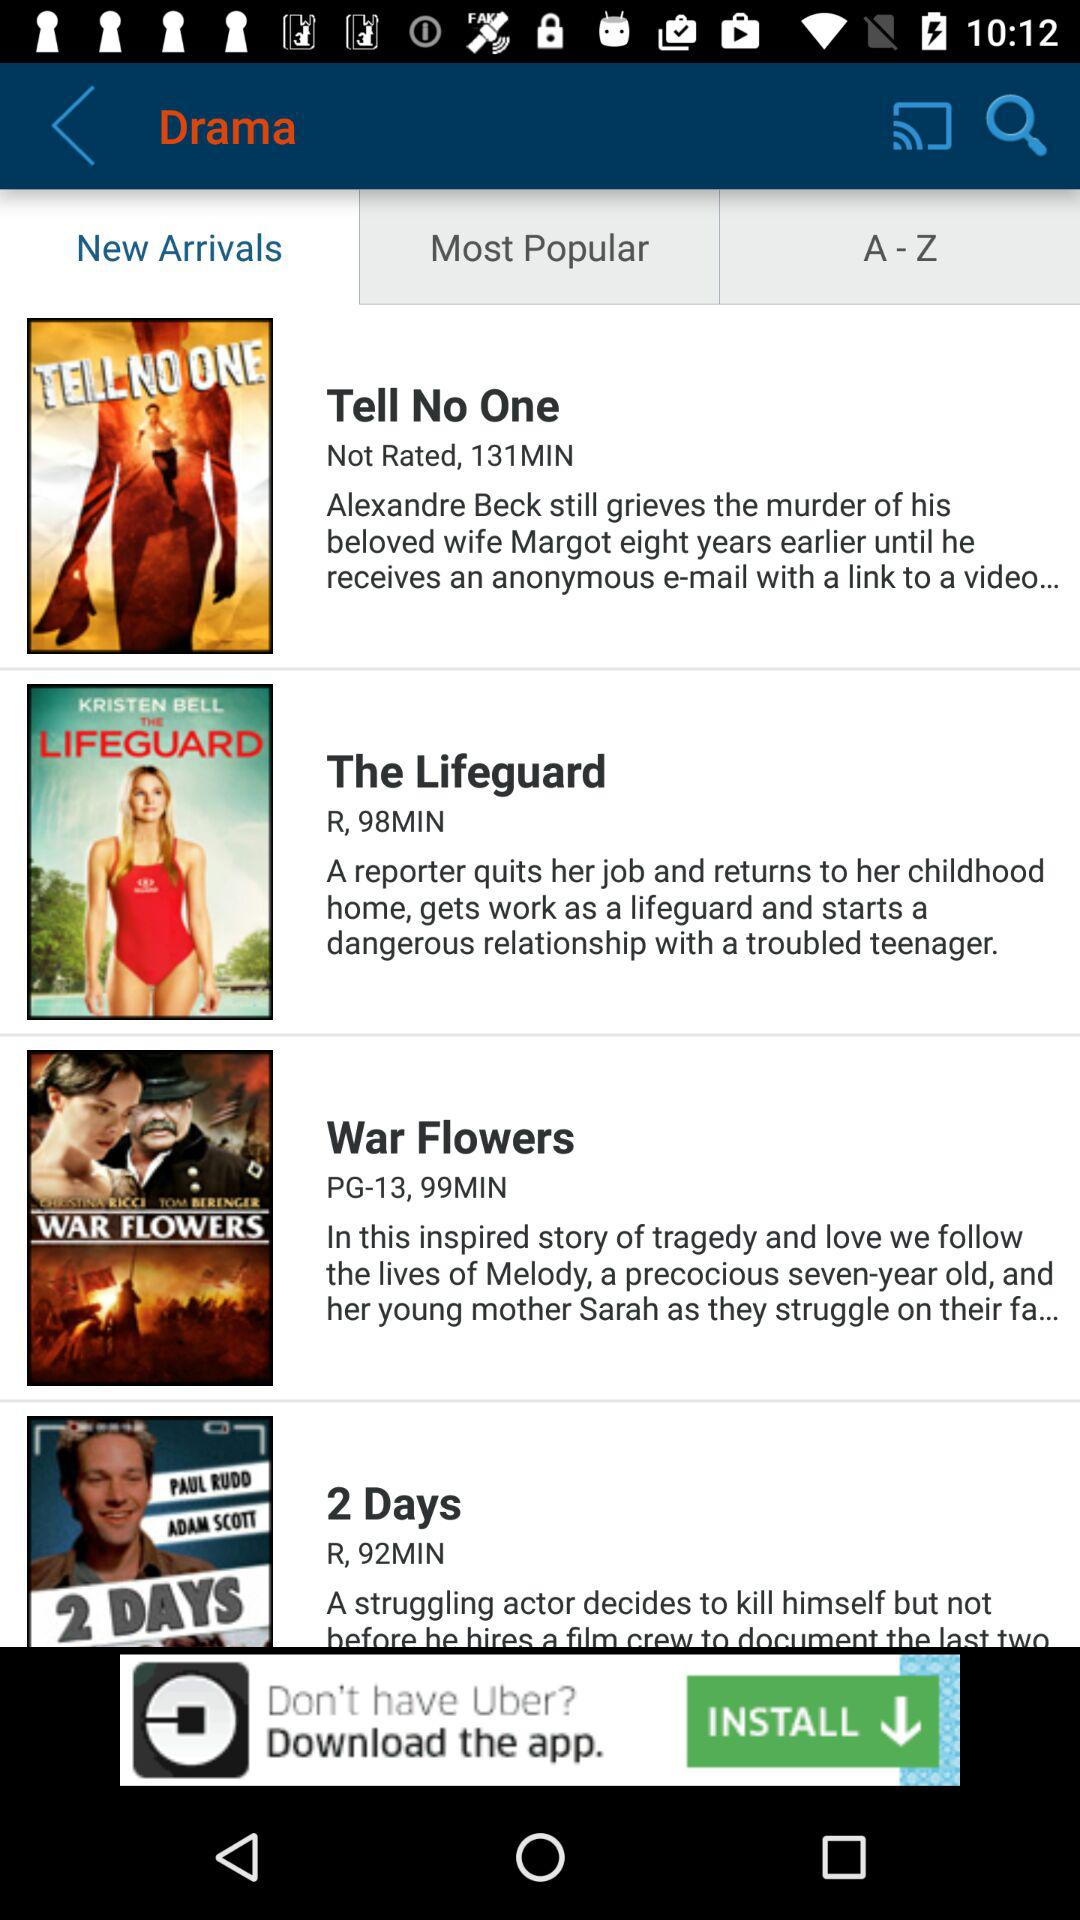Which tab is selected? The selected tab is "New Arrivals". 